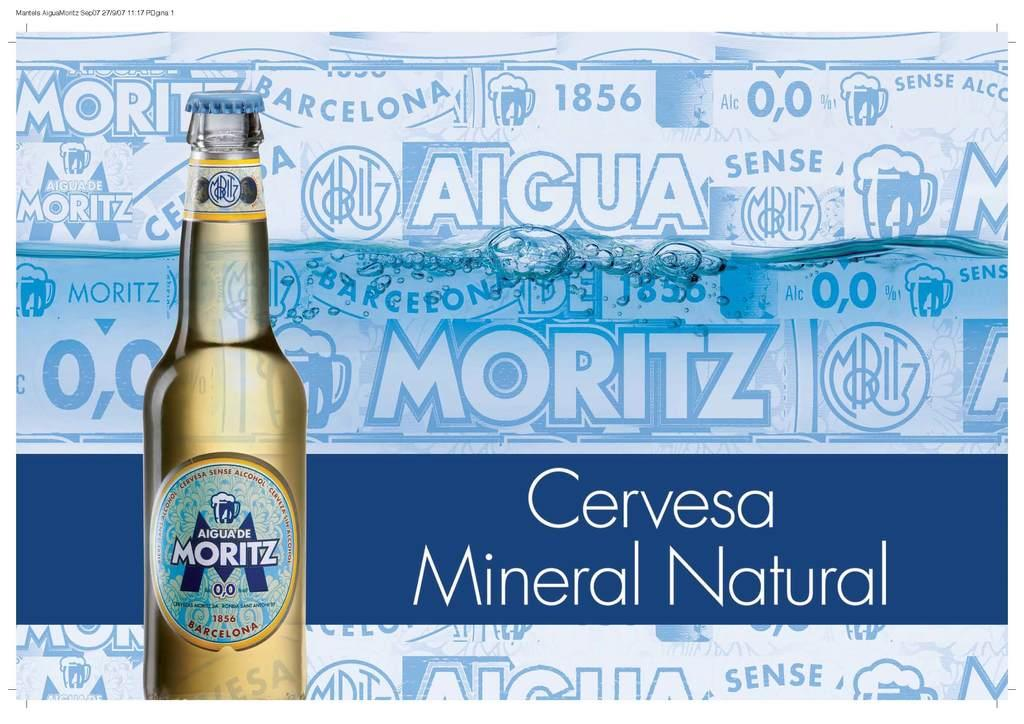Provide a one-sentence caption for the provided image. A bottle of Aigua de Moritz is displayed in an ad. 